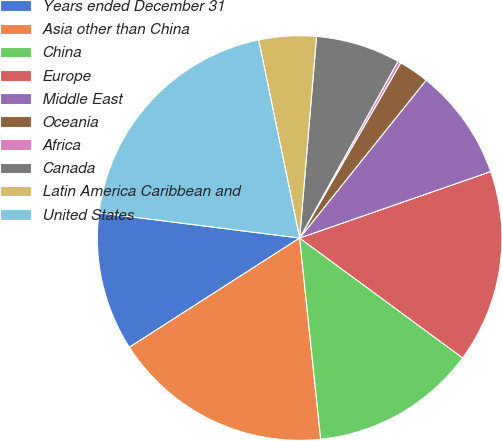Convert chart. <chart><loc_0><loc_0><loc_500><loc_500><pie_chart><fcel>Years ended December 31<fcel>Asia other than China<fcel>China<fcel>Europe<fcel>Middle East<fcel>Oceania<fcel>Africa<fcel>Canada<fcel>Latin America Caribbean and<fcel>United States<nl><fcel>11.08%<fcel>17.58%<fcel>13.25%<fcel>15.42%<fcel>8.92%<fcel>2.42%<fcel>0.25%<fcel>6.75%<fcel>4.58%<fcel>19.75%<nl></chart> 